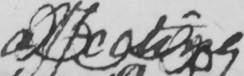Please transcribe the handwritten text in this image. affecting 